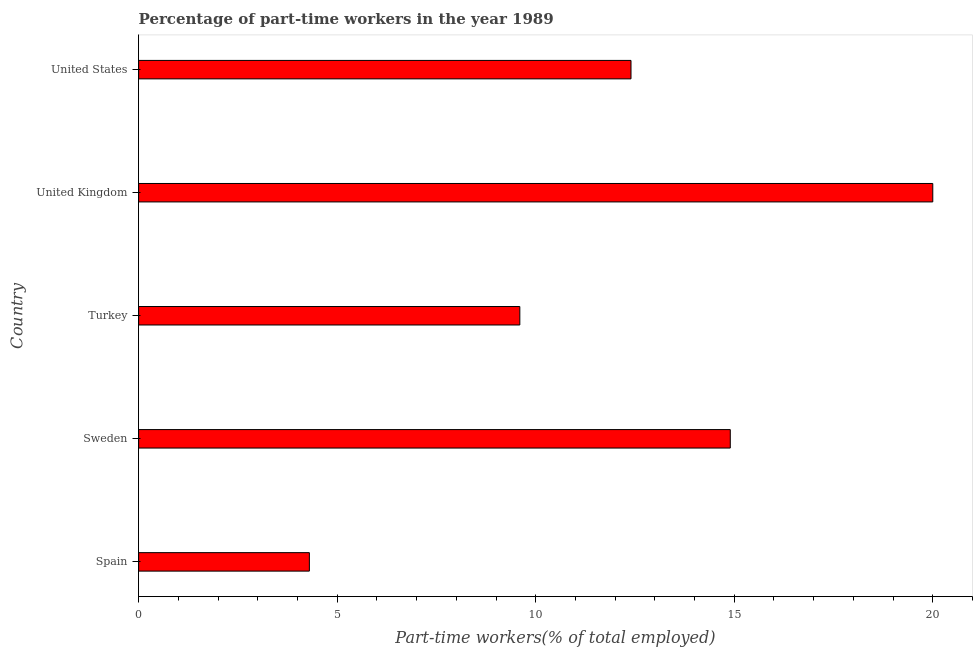Does the graph contain any zero values?
Offer a very short reply. No. What is the title of the graph?
Provide a short and direct response. Percentage of part-time workers in the year 1989. What is the label or title of the X-axis?
Keep it short and to the point. Part-time workers(% of total employed). What is the label or title of the Y-axis?
Your answer should be very brief. Country. What is the percentage of part-time workers in Sweden?
Your answer should be compact. 14.9. Across all countries, what is the minimum percentage of part-time workers?
Offer a very short reply. 4.3. In which country was the percentage of part-time workers maximum?
Make the answer very short. United Kingdom. What is the sum of the percentage of part-time workers?
Offer a very short reply. 61.2. What is the average percentage of part-time workers per country?
Keep it short and to the point. 12.24. What is the median percentage of part-time workers?
Provide a short and direct response. 12.4. What is the ratio of the percentage of part-time workers in Turkey to that in United States?
Ensure brevity in your answer.  0.77. Is the percentage of part-time workers in Turkey less than that in United Kingdom?
Make the answer very short. Yes. Is the difference between the percentage of part-time workers in Turkey and United Kingdom greater than the difference between any two countries?
Offer a very short reply. No. What is the difference between the highest and the second highest percentage of part-time workers?
Your response must be concise. 5.1. Is the sum of the percentage of part-time workers in Turkey and United Kingdom greater than the maximum percentage of part-time workers across all countries?
Provide a short and direct response. Yes. What is the difference between the highest and the lowest percentage of part-time workers?
Make the answer very short. 15.7. How many bars are there?
Make the answer very short. 5. Are all the bars in the graph horizontal?
Give a very brief answer. Yes. How many countries are there in the graph?
Ensure brevity in your answer.  5. What is the difference between two consecutive major ticks on the X-axis?
Make the answer very short. 5. Are the values on the major ticks of X-axis written in scientific E-notation?
Give a very brief answer. No. What is the Part-time workers(% of total employed) in Spain?
Your answer should be very brief. 4.3. What is the Part-time workers(% of total employed) in Sweden?
Give a very brief answer. 14.9. What is the Part-time workers(% of total employed) of Turkey?
Your answer should be very brief. 9.6. What is the Part-time workers(% of total employed) of United Kingdom?
Keep it short and to the point. 20. What is the Part-time workers(% of total employed) of United States?
Your answer should be very brief. 12.4. What is the difference between the Part-time workers(% of total employed) in Spain and United Kingdom?
Provide a short and direct response. -15.7. What is the difference between the Part-time workers(% of total employed) in Spain and United States?
Offer a very short reply. -8.1. What is the difference between the Part-time workers(% of total employed) in Sweden and Turkey?
Provide a short and direct response. 5.3. What is the difference between the Part-time workers(% of total employed) in Sweden and United States?
Offer a terse response. 2.5. What is the difference between the Part-time workers(% of total employed) in Turkey and United States?
Offer a terse response. -2.8. What is the difference between the Part-time workers(% of total employed) in United Kingdom and United States?
Offer a terse response. 7.6. What is the ratio of the Part-time workers(% of total employed) in Spain to that in Sweden?
Offer a very short reply. 0.29. What is the ratio of the Part-time workers(% of total employed) in Spain to that in Turkey?
Ensure brevity in your answer.  0.45. What is the ratio of the Part-time workers(% of total employed) in Spain to that in United Kingdom?
Ensure brevity in your answer.  0.21. What is the ratio of the Part-time workers(% of total employed) in Spain to that in United States?
Provide a short and direct response. 0.35. What is the ratio of the Part-time workers(% of total employed) in Sweden to that in Turkey?
Give a very brief answer. 1.55. What is the ratio of the Part-time workers(% of total employed) in Sweden to that in United Kingdom?
Offer a very short reply. 0.74. What is the ratio of the Part-time workers(% of total employed) in Sweden to that in United States?
Provide a short and direct response. 1.2. What is the ratio of the Part-time workers(% of total employed) in Turkey to that in United Kingdom?
Offer a terse response. 0.48. What is the ratio of the Part-time workers(% of total employed) in Turkey to that in United States?
Offer a very short reply. 0.77. What is the ratio of the Part-time workers(% of total employed) in United Kingdom to that in United States?
Offer a very short reply. 1.61. 